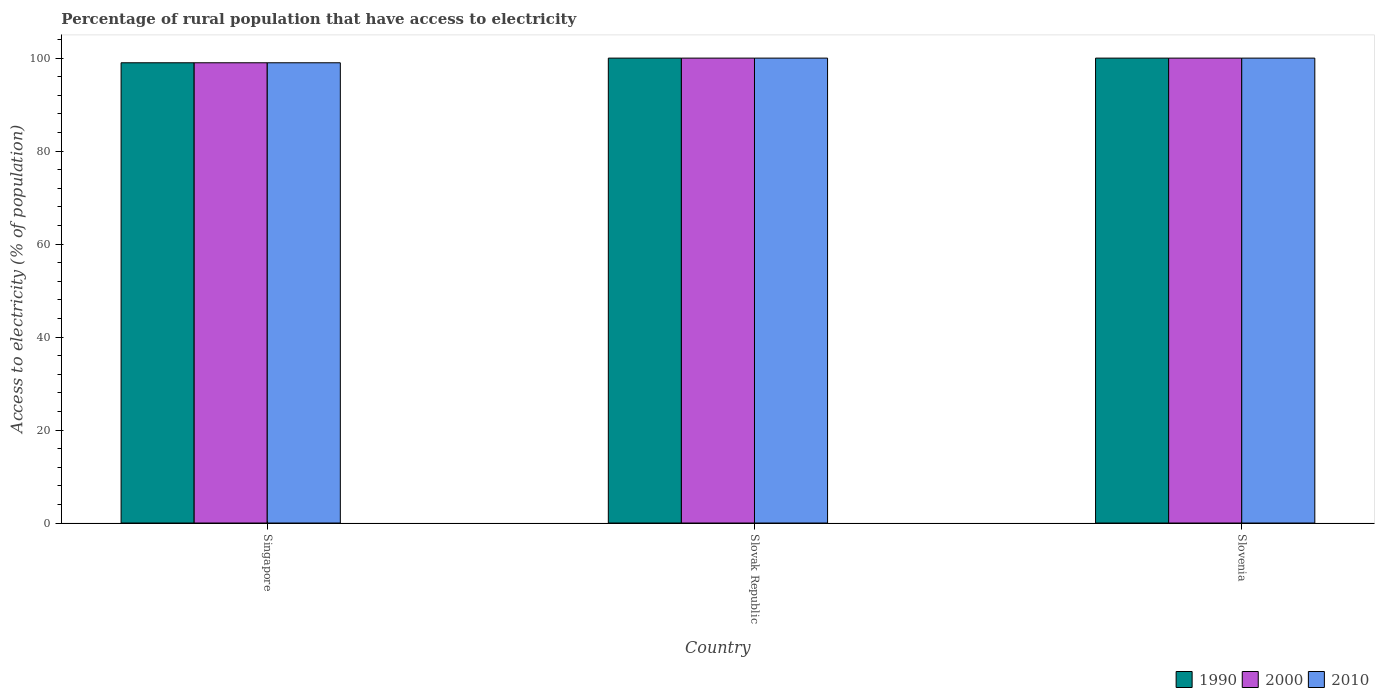How many different coloured bars are there?
Your answer should be compact. 3. Are the number of bars on each tick of the X-axis equal?
Your response must be concise. Yes. How many bars are there on the 2nd tick from the left?
Your answer should be compact. 3. How many bars are there on the 3rd tick from the right?
Give a very brief answer. 3. What is the label of the 2nd group of bars from the left?
Keep it short and to the point. Slovak Republic. In how many cases, is the number of bars for a given country not equal to the number of legend labels?
Make the answer very short. 0. In which country was the percentage of rural population that have access to electricity in 2000 maximum?
Make the answer very short. Slovak Republic. In which country was the percentage of rural population that have access to electricity in 2000 minimum?
Provide a short and direct response. Singapore. What is the total percentage of rural population that have access to electricity in 2000 in the graph?
Ensure brevity in your answer.  299. What is the average percentage of rural population that have access to electricity in 2010 per country?
Provide a succinct answer. 99.67. What is the difference between the percentage of rural population that have access to electricity of/in 1990 and percentage of rural population that have access to electricity of/in 2000 in Slovak Republic?
Offer a terse response. 0. What is the ratio of the percentage of rural population that have access to electricity in 2000 in Singapore to that in Slovenia?
Ensure brevity in your answer.  0.99. What is the difference between the highest and the second highest percentage of rural population that have access to electricity in 2000?
Offer a very short reply. -1. Is the sum of the percentage of rural population that have access to electricity in 2010 in Slovak Republic and Slovenia greater than the maximum percentage of rural population that have access to electricity in 2000 across all countries?
Your answer should be compact. Yes. What is the difference between two consecutive major ticks on the Y-axis?
Keep it short and to the point. 20. Are the values on the major ticks of Y-axis written in scientific E-notation?
Your answer should be very brief. No. Does the graph contain grids?
Ensure brevity in your answer.  No. How many legend labels are there?
Offer a very short reply. 3. What is the title of the graph?
Keep it short and to the point. Percentage of rural population that have access to electricity. What is the label or title of the Y-axis?
Your answer should be compact. Access to electricity (% of population). What is the Access to electricity (% of population) in 2000 in Singapore?
Keep it short and to the point. 99. What is the Access to electricity (% of population) in 1990 in Slovak Republic?
Your answer should be compact. 100. What is the Access to electricity (% of population) in 2000 in Slovak Republic?
Keep it short and to the point. 100. What is the Access to electricity (% of population) of 2010 in Slovak Republic?
Your answer should be very brief. 100. What is the Access to electricity (% of population) of 2000 in Slovenia?
Your response must be concise. 100. What is the Access to electricity (% of population) of 2010 in Slovenia?
Make the answer very short. 100. Across all countries, what is the maximum Access to electricity (% of population) in 1990?
Give a very brief answer. 100. Across all countries, what is the maximum Access to electricity (% of population) of 2000?
Make the answer very short. 100. Across all countries, what is the maximum Access to electricity (% of population) in 2010?
Your answer should be very brief. 100. Across all countries, what is the minimum Access to electricity (% of population) of 1990?
Keep it short and to the point. 99. Across all countries, what is the minimum Access to electricity (% of population) in 2000?
Keep it short and to the point. 99. Across all countries, what is the minimum Access to electricity (% of population) in 2010?
Ensure brevity in your answer.  99. What is the total Access to electricity (% of population) of 1990 in the graph?
Provide a short and direct response. 299. What is the total Access to electricity (% of population) of 2000 in the graph?
Give a very brief answer. 299. What is the total Access to electricity (% of population) of 2010 in the graph?
Provide a short and direct response. 299. What is the difference between the Access to electricity (% of population) in 2010 in Singapore and that in Slovak Republic?
Your answer should be very brief. -1. What is the difference between the Access to electricity (% of population) of 2000 in Slovak Republic and that in Slovenia?
Ensure brevity in your answer.  0. What is the difference between the Access to electricity (% of population) of 2000 in Singapore and the Access to electricity (% of population) of 2010 in Slovak Republic?
Give a very brief answer. -1. What is the difference between the Access to electricity (% of population) in 1990 in Slovak Republic and the Access to electricity (% of population) in 2000 in Slovenia?
Offer a very short reply. 0. What is the difference between the Access to electricity (% of population) of 1990 in Slovak Republic and the Access to electricity (% of population) of 2010 in Slovenia?
Ensure brevity in your answer.  0. What is the difference between the Access to electricity (% of population) in 2000 in Slovak Republic and the Access to electricity (% of population) in 2010 in Slovenia?
Your answer should be compact. 0. What is the average Access to electricity (% of population) in 1990 per country?
Your answer should be compact. 99.67. What is the average Access to electricity (% of population) of 2000 per country?
Ensure brevity in your answer.  99.67. What is the average Access to electricity (% of population) in 2010 per country?
Provide a succinct answer. 99.67. What is the difference between the Access to electricity (% of population) in 1990 and Access to electricity (% of population) in 2000 in Singapore?
Provide a short and direct response. 0. What is the difference between the Access to electricity (% of population) of 1990 and Access to electricity (% of population) of 2010 in Singapore?
Offer a very short reply. 0. What is the ratio of the Access to electricity (% of population) in 2000 in Singapore to that in Slovenia?
Offer a terse response. 0.99. What is the ratio of the Access to electricity (% of population) in 2010 in Singapore to that in Slovenia?
Offer a terse response. 0.99. What is the ratio of the Access to electricity (% of population) of 1990 in Slovak Republic to that in Slovenia?
Your answer should be very brief. 1. What is the ratio of the Access to electricity (% of population) of 2010 in Slovak Republic to that in Slovenia?
Your answer should be compact. 1. What is the difference between the highest and the second highest Access to electricity (% of population) in 1990?
Give a very brief answer. 0. What is the difference between the highest and the second highest Access to electricity (% of population) of 2000?
Offer a terse response. 0. What is the difference between the highest and the second highest Access to electricity (% of population) of 2010?
Give a very brief answer. 0. What is the difference between the highest and the lowest Access to electricity (% of population) of 1990?
Your response must be concise. 1. What is the difference between the highest and the lowest Access to electricity (% of population) in 2000?
Your answer should be very brief. 1. 